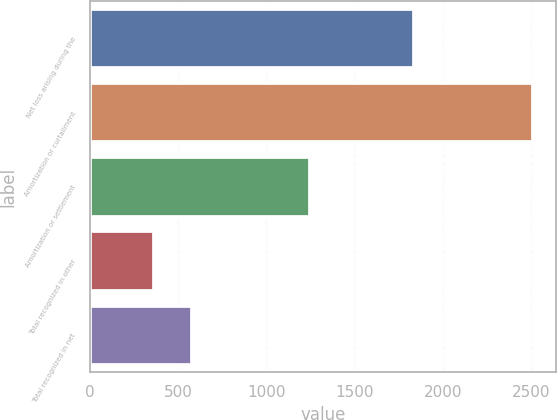<chart> <loc_0><loc_0><loc_500><loc_500><bar_chart><fcel>Net loss arising during the<fcel>Amortization or curtailment<fcel>Amortization or settlement<fcel>Total recognized in other<fcel>Total recognized in net<nl><fcel>1839<fcel>2515<fcel>1246<fcel>364<fcel>579.1<nl></chart> 